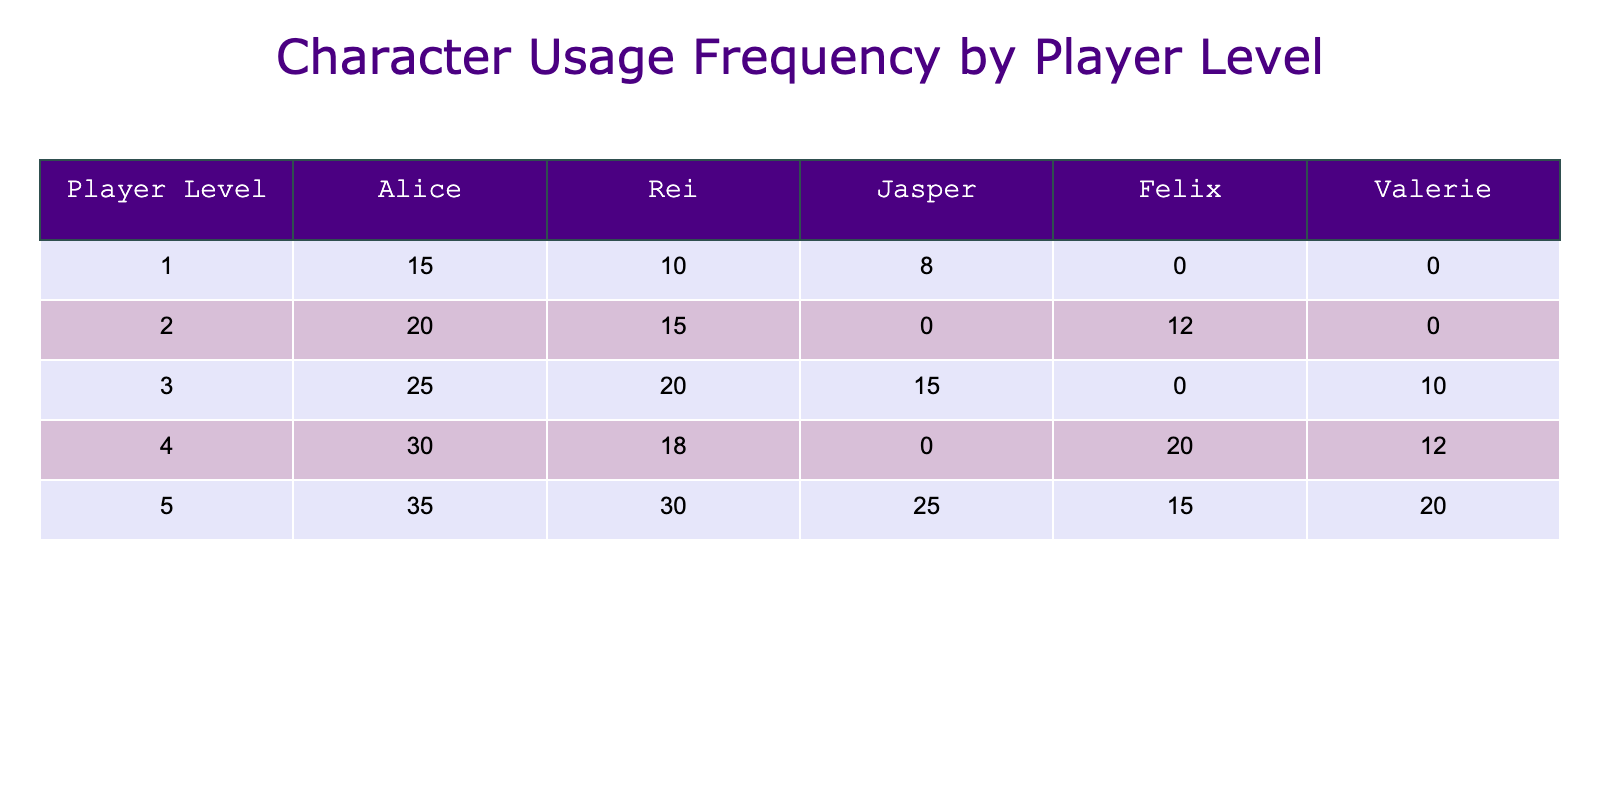What is the usage frequency of Alice at Player Level 3? Referring to the table, under Player Level 3, the usage frequency for Alice is 25.
Answer: 25 Which character has the highest total usage frequency across all player levels? To find the character with the highest total usage, I will sum the usage frequency for each character: Alice (15+20+25+30+35=125), Rei (10+15+20+18+30=93), Jasper (8+12+15+25=60), Felix (12+20+15=47), and Valerie (10+12+20=42). Since Alice has the highest sum of 125, she is the answer.
Answer: Alice What is the average usage frequency of Felix? Felix's usage frequencies are 12 (Level 2), 20 (Level 4), and 15 (Level 5). Calculating the average: (12 + 20 + 15) / 3 = 15.67.
Answer: 15.67 Was the usage frequency of Rei lower than that of Valerie at Player Level 4? At Player Level 4, Rei's usage frequency is 18, while Valerie's is 12. Since 18 is greater than 12, the statement is false.
Answer: No What is the total usage frequency for all characters at Player Level 1? At Player Level 1, the total usage frequency is obtained by summing all frequencies: Alice (15) + Rei (10) + Jasper (8) = 33.
Answer: 33 Which character had a higher usage frequency at Player Level 5, Rei or Valerie? At Player Level 5, Rei has a frequency of 30, while Valerie has a frequency of 20. Since 30 is greater than 20, Rei had a higher frequency.
Answer: Rei What is the difference in usage frequency between Alice and Jasper at Player Level 5? At Player Level 5, Alice has a frequency of 35 and Jasper has 25. The difference is calculated as 35 - 25 = 10.
Answer: 10 Is it true that Felix was used more frequently than Alice at Player Level 4? At Player Level 4, Alice's usage frequency is 30, and Felix's is 20. Since 30 is greater than 20, this statement is false.
Answer: No What character shows consistent frequency increases across all player levels from 1 to 5? By observing the frequencies, Alice's usage increases from 15 at Level 1 to 35 at Level 5. No other character consistently increases like her.
Answer: Alice 